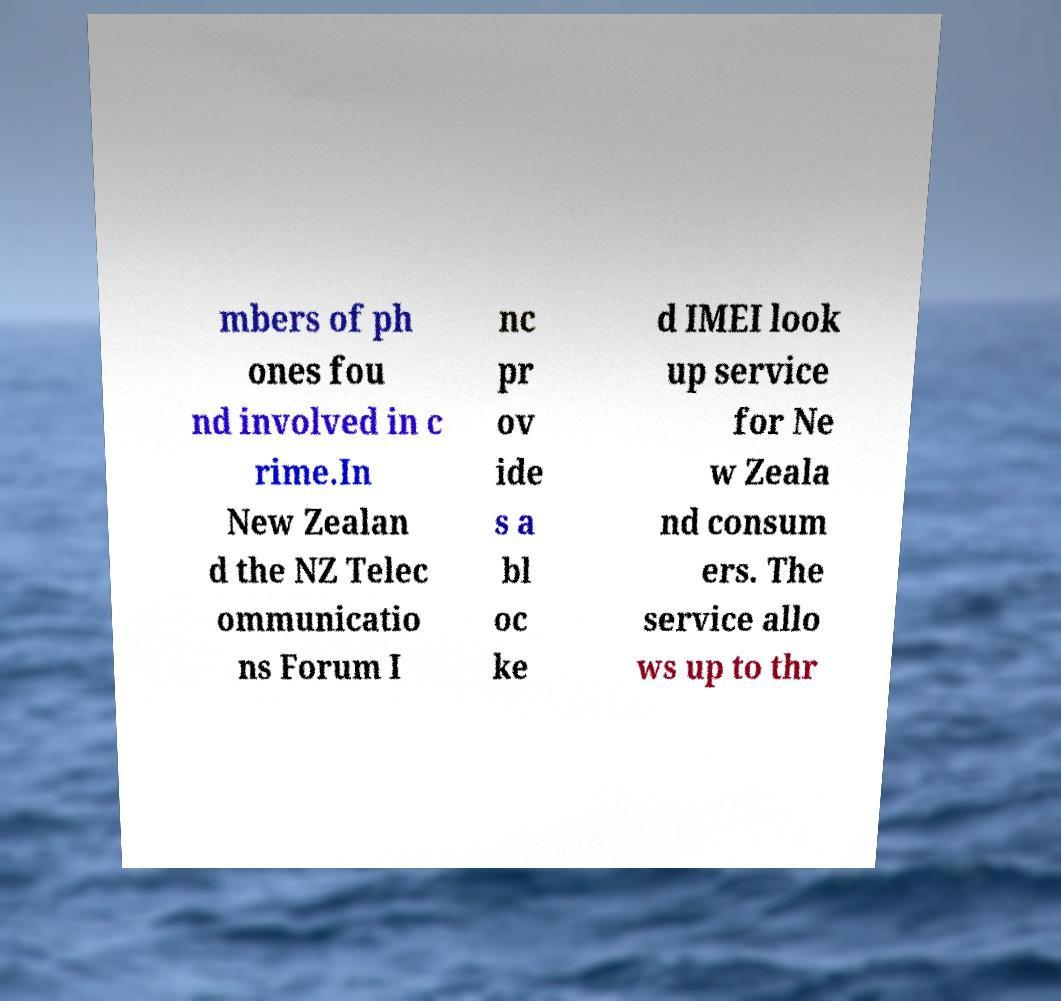Can you accurately transcribe the text from the provided image for me? mbers of ph ones fou nd involved in c rime.In New Zealan d the NZ Telec ommunicatio ns Forum I nc pr ov ide s a bl oc ke d IMEI look up service for Ne w Zeala nd consum ers. The service allo ws up to thr 